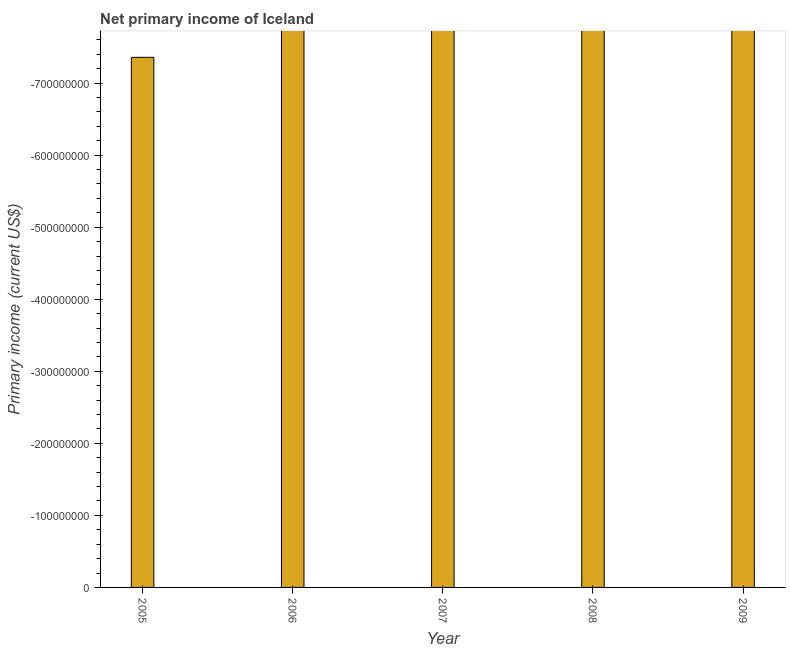What is the title of the graph?
Make the answer very short. Net primary income of Iceland. What is the label or title of the Y-axis?
Provide a short and direct response. Primary income (current US$). What is the amount of primary income in 2006?
Provide a succinct answer. 0. What is the sum of the amount of primary income?
Give a very brief answer. 0. What is the average amount of primary income per year?
Keep it short and to the point. 0. What is the median amount of primary income?
Your response must be concise. 0. How many bars are there?
Your answer should be compact. 0. Are all the bars in the graph horizontal?
Ensure brevity in your answer.  No. What is the Primary income (current US$) of 2005?
Offer a very short reply. 0. What is the Primary income (current US$) in 2006?
Keep it short and to the point. 0. What is the Primary income (current US$) in 2008?
Your response must be concise. 0. What is the Primary income (current US$) of 2009?
Provide a short and direct response. 0. 